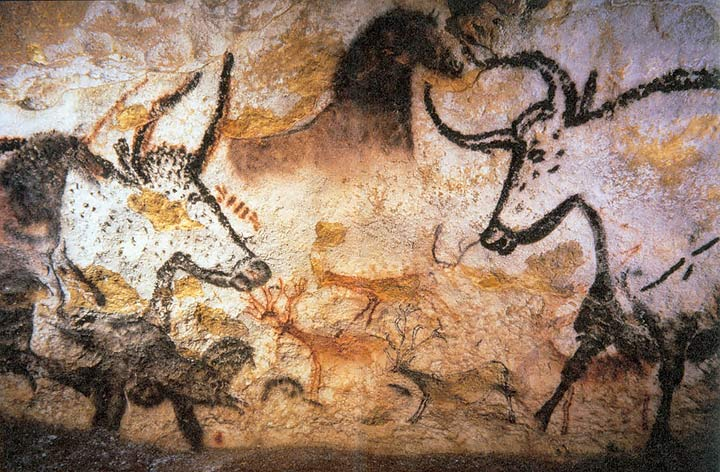What are the key elements in this picture? The image displays the renowned Lascaux Caves in France, a treasure of prehistoric art. This specific scene, illuminated by a gentle, indirect light, features vivid depictions of various animals, notably horses, bulls, and deer, which are rendered in a striking black and white against the natural reddish-brown stone. Observing from a low angle, we seem to be standing within the cave, looking up at this mural. The overlapping figures suggest a narrative of vitality and interaction among the animals. The depiction is not just an artistic expression but serves as a crucial archaeological artefact, providing insights into the cultural and spiritual lives of our Paleolithic ancestors. 